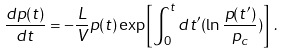<formula> <loc_0><loc_0><loc_500><loc_500>\frac { d p ( t ) } { d t } = - \frac { L } { V } p ( t ) \exp \left [ \int _ { 0 } ^ { t } d t ^ { \prime } ( \ln \frac { p ( t ^ { \prime } ) } { p _ { c } } ) \right ] \, .</formula> 